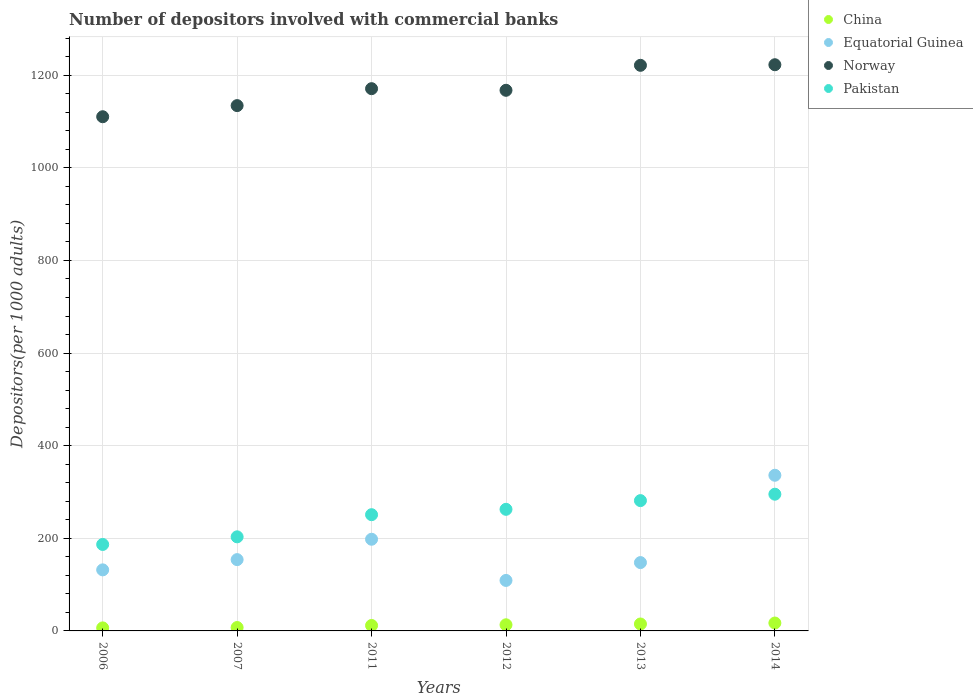How many different coloured dotlines are there?
Give a very brief answer. 4. Is the number of dotlines equal to the number of legend labels?
Ensure brevity in your answer.  Yes. What is the number of depositors involved with commercial banks in China in 2007?
Your response must be concise. 7.35. Across all years, what is the maximum number of depositors involved with commercial banks in Norway?
Ensure brevity in your answer.  1222.66. Across all years, what is the minimum number of depositors involved with commercial banks in Pakistan?
Make the answer very short. 186.7. In which year was the number of depositors involved with commercial banks in China maximum?
Keep it short and to the point. 2014. What is the total number of depositors involved with commercial banks in Pakistan in the graph?
Offer a terse response. 1480.08. What is the difference between the number of depositors involved with commercial banks in Pakistan in 2006 and that in 2013?
Give a very brief answer. -94.68. What is the difference between the number of depositors involved with commercial banks in Pakistan in 2011 and the number of depositors involved with commercial banks in Norway in 2007?
Provide a short and direct response. -883.4. What is the average number of depositors involved with commercial banks in China per year?
Your answer should be compact. 11.81. In the year 2013, what is the difference between the number of depositors involved with commercial banks in China and number of depositors involved with commercial banks in Pakistan?
Keep it short and to the point. -266.42. In how many years, is the number of depositors involved with commercial banks in Pakistan greater than 240?
Provide a succinct answer. 4. What is the ratio of the number of depositors involved with commercial banks in China in 2011 to that in 2013?
Keep it short and to the point. 0.79. Is the difference between the number of depositors involved with commercial banks in China in 2007 and 2012 greater than the difference between the number of depositors involved with commercial banks in Pakistan in 2007 and 2012?
Make the answer very short. Yes. What is the difference between the highest and the second highest number of depositors involved with commercial banks in Pakistan?
Ensure brevity in your answer.  13.85. What is the difference between the highest and the lowest number of depositors involved with commercial banks in China?
Provide a succinct answer. 10.52. Is the sum of the number of depositors involved with commercial banks in Equatorial Guinea in 2012 and 2014 greater than the maximum number of depositors involved with commercial banks in China across all years?
Ensure brevity in your answer.  Yes. Is it the case that in every year, the sum of the number of depositors involved with commercial banks in China and number of depositors involved with commercial banks in Pakistan  is greater than the sum of number of depositors involved with commercial banks in Norway and number of depositors involved with commercial banks in Equatorial Guinea?
Offer a terse response. No. Is it the case that in every year, the sum of the number of depositors involved with commercial banks in Pakistan and number of depositors involved with commercial banks in Equatorial Guinea  is greater than the number of depositors involved with commercial banks in China?
Offer a terse response. Yes. Does the number of depositors involved with commercial banks in Norway monotonically increase over the years?
Your answer should be compact. No. Is the number of depositors involved with commercial banks in China strictly greater than the number of depositors involved with commercial banks in Pakistan over the years?
Keep it short and to the point. No. Is the number of depositors involved with commercial banks in Norway strictly less than the number of depositors involved with commercial banks in China over the years?
Your answer should be very brief. No. How many dotlines are there?
Provide a succinct answer. 4. How many years are there in the graph?
Your answer should be very brief. 6. Where does the legend appear in the graph?
Offer a terse response. Top right. What is the title of the graph?
Your response must be concise. Number of depositors involved with commercial banks. What is the label or title of the Y-axis?
Provide a short and direct response. Depositors(per 1000 adults). What is the Depositors(per 1000 adults) in China in 2006?
Keep it short and to the point. 6.52. What is the Depositors(per 1000 adults) of Equatorial Guinea in 2006?
Provide a short and direct response. 131.85. What is the Depositors(per 1000 adults) in Norway in 2006?
Make the answer very short. 1110.37. What is the Depositors(per 1000 adults) in Pakistan in 2006?
Your answer should be compact. 186.7. What is the Depositors(per 1000 adults) of China in 2007?
Ensure brevity in your answer.  7.35. What is the Depositors(per 1000 adults) in Equatorial Guinea in 2007?
Your response must be concise. 153.97. What is the Depositors(per 1000 adults) of Norway in 2007?
Your response must be concise. 1134.4. What is the Depositors(per 1000 adults) of Pakistan in 2007?
Your answer should be very brief. 203.17. What is the Depositors(per 1000 adults) in China in 2011?
Make the answer very short. 11.75. What is the Depositors(per 1000 adults) of Equatorial Guinea in 2011?
Provide a succinct answer. 197.96. What is the Depositors(per 1000 adults) of Norway in 2011?
Give a very brief answer. 1170.97. What is the Depositors(per 1000 adults) of Pakistan in 2011?
Offer a terse response. 250.99. What is the Depositors(per 1000 adults) in China in 2012?
Give a very brief answer. 13.23. What is the Depositors(per 1000 adults) of Equatorial Guinea in 2012?
Your response must be concise. 109.02. What is the Depositors(per 1000 adults) in Norway in 2012?
Your answer should be very brief. 1167.46. What is the Depositors(per 1000 adults) of Pakistan in 2012?
Ensure brevity in your answer.  262.6. What is the Depositors(per 1000 adults) in China in 2013?
Provide a succinct answer. 14.96. What is the Depositors(per 1000 adults) in Equatorial Guinea in 2013?
Your answer should be very brief. 147.57. What is the Depositors(per 1000 adults) in Norway in 2013?
Ensure brevity in your answer.  1221.4. What is the Depositors(per 1000 adults) of Pakistan in 2013?
Offer a very short reply. 281.38. What is the Depositors(per 1000 adults) in China in 2014?
Offer a terse response. 17.04. What is the Depositors(per 1000 adults) in Equatorial Guinea in 2014?
Provide a succinct answer. 336.14. What is the Depositors(per 1000 adults) in Norway in 2014?
Give a very brief answer. 1222.66. What is the Depositors(per 1000 adults) of Pakistan in 2014?
Keep it short and to the point. 295.23. Across all years, what is the maximum Depositors(per 1000 adults) in China?
Offer a very short reply. 17.04. Across all years, what is the maximum Depositors(per 1000 adults) of Equatorial Guinea?
Keep it short and to the point. 336.14. Across all years, what is the maximum Depositors(per 1000 adults) of Norway?
Your answer should be very brief. 1222.66. Across all years, what is the maximum Depositors(per 1000 adults) in Pakistan?
Provide a short and direct response. 295.23. Across all years, what is the minimum Depositors(per 1000 adults) of China?
Offer a very short reply. 6.52. Across all years, what is the minimum Depositors(per 1000 adults) in Equatorial Guinea?
Your answer should be very brief. 109.02. Across all years, what is the minimum Depositors(per 1000 adults) of Norway?
Provide a succinct answer. 1110.37. Across all years, what is the minimum Depositors(per 1000 adults) of Pakistan?
Your response must be concise. 186.7. What is the total Depositors(per 1000 adults) in China in the graph?
Your response must be concise. 70.86. What is the total Depositors(per 1000 adults) in Equatorial Guinea in the graph?
Ensure brevity in your answer.  1076.51. What is the total Depositors(per 1000 adults) of Norway in the graph?
Keep it short and to the point. 7027.26. What is the total Depositors(per 1000 adults) of Pakistan in the graph?
Your answer should be very brief. 1480.08. What is the difference between the Depositors(per 1000 adults) of China in 2006 and that in 2007?
Your response must be concise. -0.83. What is the difference between the Depositors(per 1000 adults) in Equatorial Guinea in 2006 and that in 2007?
Give a very brief answer. -22.13. What is the difference between the Depositors(per 1000 adults) of Norway in 2006 and that in 2007?
Your answer should be very brief. -24.03. What is the difference between the Depositors(per 1000 adults) of Pakistan in 2006 and that in 2007?
Offer a terse response. -16.47. What is the difference between the Depositors(per 1000 adults) in China in 2006 and that in 2011?
Your answer should be compact. -5.23. What is the difference between the Depositors(per 1000 adults) in Equatorial Guinea in 2006 and that in 2011?
Provide a succinct answer. -66.12. What is the difference between the Depositors(per 1000 adults) of Norway in 2006 and that in 2011?
Your response must be concise. -60.6. What is the difference between the Depositors(per 1000 adults) of Pakistan in 2006 and that in 2011?
Offer a terse response. -64.29. What is the difference between the Depositors(per 1000 adults) in China in 2006 and that in 2012?
Make the answer very short. -6.71. What is the difference between the Depositors(per 1000 adults) of Equatorial Guinea in 2006 and that in 2012?
Your answer should be compact. 22.83. What is the difference between the Depositors(per 1000 adults) of Norway in 2006 and that in 2012?
Provide a succinct answer. -57.1. What is the difference between the Depositors(per 1000 adults) in Pakistan in 2006 and that in 2012?
Ensure brevity in your answer.  -75.9. What is the difference between the Depositors(per 1000 adults) of China in 2006 and that in 2013?
Your response must be concise. -8.44. What is the difference between the Depositors(per 1000 adults) in Equatorial Guinea in 2006 and that in 2013?
Make the answer very short. -15.72. What is the difference between the Depositors(per 1000 adults) in Norway in 2006 and that in 2013?
Make the answer very short. -111.03. What is the difference between the Depositors(per 1000 adults) in Pakistan in 2006 and that in 2013?
Make the answer very short. -94.68. What is the difference between the Depositors(per 1000 adults) in China in 2006 and that in 2014?
Provide a short and direct response. -10.52. What is the difference between the Depositors(per 1000 adults) in Equatorial Guinea in 2006 and that in 2014?
Your answer should be compact. -204.3. What is the difference between the Depositors(per 1000 adults) of Norway in 2006 and that in 2014?
Provide a succinct answer. -112.29. What is the difference between the Depositors(per 1000 adults) in Pakistan in 2006 and that in 2014?
Give a very brief answer. -108.53. What is the difference between the Depositors(per 1000 adults) in China in 2007 and that in 2011?
Your answer should be compact. -4.4. What is the difference between the Depositors(per 1000 adults) of Equatorial Guinea in 2007 and that in 2011?
Offer a terse response. -43.99. What is the difference between the Depositors(per 1000 adults) of Norway in 2007 and that in 2011?
Provide a short and direct response. -36.57. What is the difference between the Depositors(per 1000 adults) of Pakistan in 2007 and that in 2011?
Provide a short and direct response. -47.82. What is the difference between the Depositors(per 1000 adults) in China in 2007 and that in 2012?
Keep it short and to the point. -5.88. What is the difference between the Depositors(per 1000 adults) in Equatorial Guinea in 2007 and that in 2012?
Ensure brevity in your answer.  44.95. What is the difference between the Depositors(per 1000 adults) in Norway in 2007 and that in 2012?
Your answer should be compact. -33.07. What is the difference between the Depositors(per 1000 adults) of Pakistan in 2007 and that in 2012?
Offer a terse response. -59.43. What is the difference between the Depositors(per 1000 adults) in China in 2007 and that in 2013?
Ensure brevity in your answer.  -7.61. What is the difference between the Depositors(per 1000 adults) in Equatorial Guinea in 2007 and that in 2013?
Offer a very short reply. 6.4. What is the difference between the Depositors(per 1000 adults) of Norway in 2007 and that in 2013?
Your answer should be very brief. -87.01. What is the difference between the Depositors(per 1000 adults) in Pakistan in 2007 and that in 2013?
Your answer should be very brief. -78.21. What is the difference between the Depositors(per 1000 adults) in China in 2007 and that in 2014?
Offer a very short reply. -9.69. What is the difference between the Depositors(per 1000 adults) in Equatorial Guinea in 2007 and that in 2014?
Give a very brief answer. -182.17. What is the difference between the Depositors(per 1000 adults) of Norway in 2007 and that in 2014?
Your answer should be compact. -88.26. What is the difference between the Depositors(per 1000 adults) in Pakistan in 2007 and that in 2014?
Offer a terse response. -92.06. What is the difference between the Depositors(per 1000 adults) of China in 2011 and that in 2012?
Keep it short and to the point. -1.48. What is the difference between the Depositors(per 1000 adults) in Equatorial Guinea in 2011 and that in 2012?
Make the answer very short. 88.94. What is the difference between the Depositors(per 1000 adults) in Norway in 2011 and that in 2012?
Your answer should be compact. 3.5. What is the difference between the Depositors(per 1000 adults) in Pakistan in 2011 and that in 2012?
Offer a terse response. -11.61. What is the difference between the Depositors(per 1000 adults) of China in 2011 and that in 2013?
Give a very brief answer. -3.21. What is the difference between the Depositors(per 1000 adults) of Equatorial Guinea in 2011 and that in 2013?
Your answer should be very brief. 50.39. What is the difference between the Depositors(per 1000 adults) of Norway in 2011 and that in 2013?
Give a very brief answer. -50.44. What is the difference between the Depositors(per 1000 adults) in Pakistan in 2011 and that in 2013?
Your response must be concise. -30.39. What is the difference between the Depositors(per 1000 adults) in China in 2011 and that in 2014?
Offer a very short reply. -5.29. What is the difference between the Depositors(per 1000 adults) in Equatorial Guinea in 2011 and that in 2014?
Give a very brief answer. -138.18. What is the difference between the Depositors(per 1000 adults) of Norway in 2011 and that in 2014?
Keep it short and to the point. -51.69. What is the difference between the Depositors(per 1000 adults) in Pakistan in 2011 and that in 2014?
Provide a succinct answer. -44.24. What is the difference between the Depositors(per 1000 adults) in China in 2012 and that in 2013?
Give a very brief answer. -1.73. What is the difference between the Depositors(per 1000 adults) of Equatorial Guinea in 2012 and that in 2013?
Your answer should be very brief. -38.55. What is the difference between the Depositors(per 1000 adults) in Norway in 2012 and that in 2013?
Offer a terse response. -53.94. What is the difference between the Depositors(per 1000 adults) in Pakistan in 2012 and that in 2013?
Your response must be concise. -18.78. What is the difference between the Depositors(per 1000 adults) in China in 2012 and that in 2014?
Your answer should be compact. -3.81. What is the difference between the Depositors(per 1000 adults) in Equatorial Guinea in 2012 and that in 2014?
Give a very brief answer. -227.12. What is the difference between the Depositors(per 1000 adults) of Norway in 2012 and that in 2014?
Keep it short and to the point. -55.2. What is the difference between the Depositors(per 1000 adults) in Pakistan in 2012 and that in 2014?
Offer a very short reply. -32.63. What is the difference between the Depositors(per 1000 adults) in China in 2013 and that in 2014?
Your response must be concise. -2.08. What is the difference between the Depositors(per 1000 adults) in Equatorial Guinea in 2013 and that in 2014?
Offer a very short reply. -188.57. What is the difference between the Depositors(per 1000 adults) in Norway in 2013 and that in 2014?
Keep it short and to the point. -1.26. What is the difference between the Depositors(per 1000 adults) of Pakistan in 2013 and that in 2014?
Ensure brevity in your answer.  -13.85. What is the difference between the Depositors(per 1000 adults) in China in 2006 and the Depositors(per 1000 adults) in Equatorial Guinea in 2007?
Offer a terse response. -147.45. What is the difference between the Depositors(per 1000 adults) in China in 2006 and the Depositors(per 1000 adults) in Norway in 2007?
Offer a terse response. -1127.88. What is the difference between the Depositors(per 1000 adults) of China in 2006 and the Depositors(per 1000 adults) of Pakistan in 2007?
Offer a very short reply. -196.65. What is the difference between the Depositors(per 1000 adults) of Equatorial Guinea in 2006 and the Depositors(per 1000 adults) of Norway in 2007?
Your answer should be very brief. -1002.55. What is the difference between the Depositors(per 1000 adults) of Equatorial Guinea in 2006 and the Depositors(per 1000 adults) of Pakistan in 2007?
Provide a succinct answer. -71.32. What is the difference between the Depositors(per 1000 adults) of Norway in 2006 and the Depositors(per 1000 adults) of Pakistan in 2007?
Make the answer very short. 907.2. What is the difference between the Depositors(per 1000 adults) of China in 2006 and the Depositors(per 1000 adults) of Equatorial Guinea in 2011?
Your response must be concise. -191.44. What is the difference between the Depositors(per 1000 adults) in China in 2006 and the Depositors(per 1000 adults) in Norway in 2011?
Ensure brevity in your answer.  -1164.45. What is the difference between the Depositors(per 1000 adults) of China in 2006 and the Depositors(per 1000 adults) of Pakistan in 2011?
Keep it short and to the point. -244.47. What is the difference between the Depositors(per 1000 adults) of Equatorial Guinea in 2006 and the Depositors(per 1000 adults) of Norway in 2011?
Your answer should be very brief. -1039.12. What is the difference between the Depositors(per 1000 adults) of Equatorial Guinea in 2006 and the Depositors(per 1000 adults) of Pakistan in 2011?
Provide a short and direct response. -119.15. What is the difference between the Depositors(per 1000 adults) in Norway in 2006 and the Depositors(per 1000 adults) in Pakistan in 2011?
Provide a short and direct response. 859.38. What is the difference between the Depositors(per 1000 adults) of China in 2006 and the Depositors(per 1000 adults) of Equatorial Guinea in 2012?
Offer a terse response. -102.5. What is the difference between the Depositors(per 1000 adults) of China in 2006 and the Depositors(per 1000 adults) of Norway in 2012?
Ensure brevity in your answer.  -1160.95. What is the difference between the Depositors(per 1000 adults) in China in 2006 and the Depositors(per 1000 adults) in Pakistan in 2012?
Your answer should be compact. -256.08. What is the difference between the Depositors(per 1000 adults) of Equatorial Guinea in 2006 and the Depositors(per 1000 adults) of Norway in 2012?
Offer a terse response. -1035.62. What is the difference between the Depositors(per 1000 adults) in Equatorial Guinea in 2006 and the Depositors(per 1000 adults) in Pakistan in 2012?
Ensure brevity in your answer.  -130.75. What is the difference between the Depositors(per 1000 adults) in Norway in 2006 and the Depositors(per 1000 adults) in Pakistan in 2012?
Offer a terse response. 847.77. What is the difference between the Depositors(per 1000 adults) in China in 2006 and the Depositors(per 1000 adults) in Equatorial Guinea in 2013?
Offer a terse response. -141.05. What is the difference between the Depositors(per 1000 adults) of China in 2006 and the Depositors(per 1000 adults) of Norway in 2013?
Your answer should be very brief. -1214.88. What is the difference between the Depositors(per 1000 adults) in China in 2006 and the Depositors(per 1000 adults) in Pakistan in 2013?
Give a very brief answer. -274.86. What is the difference between the Depositors(per 1000 adults) of Equatorial Guinea in 2006 and the Depositors(per 1000 adults) of Norway in 2013?
Ensure brevity in your answer.  -1089.56. What is the difference between the Depositors(per 1000 adults) in Equatorial Guinea in 2006 and the Depositors(per 1000 adults) in Pakistan in 2013?
Your response must be concise. -149.53. What is the difference between the Depositors(per 1000 adults) in Norway in 2006 and the Depositors(per 1000 adults) in Pakistan in 2013?
Your answer should be compact. 828.99. What is the difference between the Depositors(per 1000 adults) of China in 2006 and the Depositors(per 1000 adults) of Equatorial Guinea in 2014?
Make the answer very short. -329.62. What is the difference between the Depositors(per 1000 adults) of China in 2006 and the Depositors(per 1000 adults) of Norway in 2014?
Offer a very short reply. -1216.14. What is the difference between the Depositors(per 1000 adults) of China in 2006 and the Depositors(per 1000 adults) of Pakistan in 2014?
Make the answer very short. -288.71. What is the difference between the Depositors(per 1000 adults) in Equatorial Guinea in 2006 and the Depositors(per 1000 adults) in Norway in 2014?
Your answer should be very brief. -1090.82. What is the difference between the Depositors(per 1000 adults) in Equatorial Guinea in 2006 and the Depositors(per 1000 adults) in Pakistan in 2014?
Your response must be concise. -163.39. What is the difference between the Depositors(per 1000 adults) of Norway in 2006 and the Depositors(per 1000 adults) of Pakistan in 2014?
Provide a succinct answer. 815.14. What is the difference between the Depositors(per 1000 adults) of China in 2007 and the Depositors(per 1000 adults) of Equatorial Guinea in 2011?
Your response must be concise. -190.61. What is the difference between the Depositors(per 1000 adults) in China in 2007 and the Depositors(per 1000 adults) in Norway in 2011?
Your answer should be compact. -1163.62. What is the difference between the Depositors(per 1000 adults) of China in 2007 and the Depositors(per 1000 adults) of Pakistan in 2011?
Offer a terse response. -243.64. What is the difference between the Depositors(per 1000 adults) of Equatorial Guinea in 2007 and the Depositors(per 1000 adults) of Norway in 2011?
Give a very brief answer. -1016.99. What is the difference between the Depositors(per 1000 adults) of Equatorial Guinea in 2007 and the Depositors(per 1000 adults) of Pakistan in 2011?
Provide a short and direct response. -97.02. What is the difference between the Depositors(per 1000 adults) of Norway in 2007 and the Depositors(per 1000 adults) of Pakistan in 2011?
Ensure brevity in your answer.  883.4. What is the difference between the Depositors(per 1000 adults) of China in 2007 and the Depositors(per 1000 adults) of Equatorial Guinea in 2012?
Give a very brief answer. -101.67. What is the difference between the Depositors(per 1000 adults) of China in 2007 and the Depositors(per 1000 adults) of Norway in 2012?
Provide a short and direct response. -1160.11. What is the difference between the Depositors(per 1000 adults) in China in 2007 and the Depositors(per 1000 adults) in Pakistan in 2012?
Your answer should be very brief. -255.25. What is the difference between the Depositors(per 1000 adults) in Equatorial Guinea in 2007 and the Depositors(per 1000 adults) in Norway in 2012?
Make the answer very short. -1013.49. What is the difference between the Depositors(per 1000 adults) in Equatorial Guinea in 2007 and the Depositors(per 1000 adults) in Pakistan in 2012?
Give a very brief answer. -108.63. What is the difference between the Depositors(per 1000 adults) of Norway in 2007 and the Depositors(per 1000 adults) of Pakistan in 2012?
Make the answer very short. 871.8. What is the difference between the Depositors(per 1000 adults) of China in 2007 and the Depositors(per 1000 adults) of Equatorial Guinea in 2013?
Ensure brevity in your answer.  -140.22. What is the difference between the Depositors(per 1000 adults) in China in 2007 and the Depositors(per 1000 adults) in Norway in 2013?
Your response must be concise. -1214.05. What is the difference between the Depositors(per 1000 adults) of China in 2007 and the Depositors(per 1000 adults) of Pakistan in 2013?
Offer a very short reply. -274.03. What is the difference between the Depositors(per 1000 adults) in Equatorial Guinea in 2007 and the Depositors(per 1000 adults) in Norway in 2013?
Provide a short and direct response. -1067.43. What is the difference between the Depositors(per 1000 adults) of Equatorial Guinea in 2007 and the Depositors(per 1000 adults) of Pakistan in 2013?
Your response must be concise. -127.41. What is the difference between the Depositors(per 1000 adults) in Norway in 2007 and the Depositors(per 1000 adults) in Pakistan in 2013?
Your answer should be very brief. 853.02. What is the difference between the Depositors(per 1000 adults) of China in 2007 and the Depositors(per 1000 adults) of Equatorial Guinea in 2014?
Make the answer very short. -328.79. What is the difference between the Depositors(per 1000 adults) of China in 2007 and the Depositors(per 1000 adults) of Norway in 2014?
Give a very brief answer. -1215.31. What is the difference between the Depositors(per 1000 adults) in China in 2007 and the Depositors(per 1000 adults) in Pakistan in 2014?
Offer a terse response. -287.88. What is the difference between the Depositors(per 1000 adults) of Equatorial Guinea in 2007 and the Depositors(per 1000 adults) of Norway in 2014?
Your answer should be very brief. -1068.69. What is the difference between the Depositors(per 1000 adults) of Equatorial Guinea in 2007 and the Depositors(per 1000 adults) of Pakistan in 2014?
Your answer should be very brief. -141.26. What is the difference between the Depositors(per 1000 adults) of Norway in 2007 and the Depositors(per 1000 adults) of Pakistan in 2014?
Offer a very short reply. 839.16. What is the difference between the Depositors(per 1000 adults) of China in 2011 and the Depositors(per 1000 adults) of Equatorial Guinea in 2012?
Offer a very short reply. -97.27. What is the difference between the Depositors(per 1000 adults) of China in 2011 and the Depositors(per 1000 adults) of Norway in 2012?
Offer a very short reply. -1155.71. What is the difference between the Depositors(per 1000 adults) of China in 2011 and the Depositors(per 1000 adults) of Pakistan in 2012?
Keep it short and to the point. -250.85. What is the difference between the Depositors(per 1000 adults) of Equatorial Guinea in 2011 and the Depositors(per 1000 adults) of Norway in 2012?
Your answer should be very brief. -969.5. What is the difference between the Depositors(per 1000 adults) of Equatorial Guinea in 2011 and the Depositors(per 1000 adults) of Pakistan in 2012?
Ensure brevity in your answer.  -64.64. What is the difference between the Depositors(per 1000 adults) in Norway in 2011 and the Depositors(per 1000 adults) in Pakistan in 2012?
Provide a short and direct response. 908.37. What is the difference between the Depositors(per 1000 adults) in China in 2011 and the Depositors(per 1000 adults) in Equatorial Guinea in 2013?
Offer a very short reply. -135.82. What is the difference between the Depositors(per 1000 adults) in China in 2011 and the Depositors(per 1000 adults) in Norway in 2013?
Make the answer very short. -1209.65. What is the difference between the Depositors(per 1000 adults) of China in 2011 and the Depositors(per 1000 adults) of Pakistan in 2013?
Offer a terse response. -269.63. What is the difference between the Depositors(per 1000 adults) in Equatorial Guinea in 2011 and the Depositors(per 1000 adults) in Norway in 2013?
Provide a short and direct response. -1023.44. What is the difference between the Depositors(per 1000 adults) in Equatorial Guinea in 2011 and the Depositors(per 1000 adults) in Pakistan in 2013?
Make the answer very short. -83.42. What is the difference between the Depositors(per 1000 adults) of Norway in 2011 and the Depositors(per 1000 adults) of Pakistan in 2013?
Offer a terse response. 889.59. What is the difference between the Depositors(per 1000 adults) in China in 2011 and the Depositors(per 1000 adults) in Equatorial Guinea in 2014?
Your answer should be very brief. -324.39. What is the difference between the Depositors(per 1000 adults) in China in 2011 and the Depositors(per 1000 adults) in Norway in 2014?
Offer a terse response. -1210.91. What is the difference between the Depositors(per 1000 adults) of China in 2011 and the Depositors(per 1000 adults) of Pakistan in 2014?
Ensure brevity in your answer.  -283.48. What is the difference between the Depositors(per 1000 adults) of Equatorial Guinea in 2011 and the Depositors(per 1000 adults) of Norway in 2014?
Your answer should be compact. -1024.7. What is the difference between the Depositors(per 1000 adults) of Equatorial Guinea in 2011 and the Depositors(per 1000 adults) of Pakistan in 2014?
Give a very brief answer. -97.27. What is the difference between the Depositors(per 1000 adults) in Norway in 2011 and the Depositors(per 1000 adults) in Pakistan in 2014?
Make the answer very short. 875.73. What is the difference between the Depositors(per 1000 adults) in China in 2012 and the Depositors(per 1000 adults) in Equatorial Guinea in 2013?
Make the answer very short. -134.34. What is the difference between the Depositors(per 1000 adults) of China in 2012 and the Depositors(per 1000 adults) of Norway in 2013?
Your answer should be very brief. -1208.17. What is the difference between the Depositors(per 1000 adults) in China in 2012 and the Depositors(per 1000 adults) in Pakistan in 2013?
Provide a succinct answer. -268.15. What is the difference between the Depositors(per 1000 adults) in Equatorial Guinea in 2012 and the Depositors(per 1000 adults) in Norway in 2013?
Ensure brevity in your answer.  -1112.38. What is the difference between the Depositors(per 1000 adults) in Equatorial Guinea in 2012 and the Depositors(per 1000 adults) in Pakistan in 2013?
Your answer should be compact. -172.36. What is the difference between the Depositors(per 1000 adults) of Norway in 2012 and the Depositors(per 1000 adults) of Pakistan in 2013?
Offer a terse response. 886.08. What is the difference between the Depositors(per 1000 adults) of China in 2012 and the Depositors(per 1000 adults) of Equatorial Guinea in 2014?
Ensure brevity in your answer.  -322.91. What is the difference between the Depositors(per 1000 adults) of China in 2012 and the Depositors(per 1000 adults) of Norway in 2014?
Ensure brevity in your answer.  -1209.43. What is the difference between the Depositors(per 1000 adults) in China in 2012 and the Depositors(per 1000 adults) in Pakistan in 2014?
Your answer should be compact. -282. What is the difference between the Depositors(per 1000 adults) in Equatorial Guinea in 2012 and the Depositors(per 1000 adults) in Norway in 2014?
Ensure brevity in your answer.  -1113.64. What is the difference between the Depositors(per 1000 adults) of Equatorial Guinea in 2012 and the Depositors(per 1000 adults) of Pakistan in 2014?
Keep it short and to the point. -186.21. What is the difference between the Depositors(per 1000 adults) in Norway in 2012 and the Depositors(per 1000 adults) in Pakistan in 2014?
Keep it short and to the point. 872.23. What is the difference between the Depositors(per 1000 adults) in China in 2013 and the Depositors(per 1000 adults) in Equatorial Guinea in 2014?
Provide a short and direct response. -321.18. What is the difference between the Depositors(per 1000 adults) in China in 2013 and the Depositors(per 1000 adults) in Norway in 2014?
Ensure brevity in your answer.  -1207.7. What is the difference between the Depositors(per 1000 adults) of China in 2013 and the Depositors(per 1000 adults) of Pakistan in 2014?
Give a very brief answer. -280.27. What is the difference between the Depositors(per 1000 adults) in Equatorial Guinea in 2013 and the Depositors(per 1000 adults) in Norway in 2014?
Provide a short and direct response. -1075.09. What is the difference between the Depositors(per 1000 adults) of Equatorial Guinea in 2013 and the Depositors(per 1000 adults) of Pakistan in 2014?
Give a very brief answer. -147.66. What is the difference between the Depositors(per 1000 adults) of Norway in 2013 and the Depositors(per 1000 adults) of Pakistan in 2014?
Give a very brief answer. 926.17. What is the average Depositors(per 1000 adults) of China per year?
Offer a very short reply. 11.81. What is the average Depositors(per 1000 adults) of Equatorial Guinea per year?
Ensure brevity in your answer.  179.42. What is the average Depositors(per 1000 adults) of Norway per year?
Your answer should be compact. 1171.21. What is the average Depositors(per 1000 adults) in Pakistan per year?
Give a very brief answer. 246.68. In the year 2006, what is the difference between the Depositors(per 1000 adults) in China and Depositors(per 1000 adults) in Equatorial Guinea?
Keep it short and to the point. -125.33. In the year 2006, what is the difference between the Depositors(per 1000 adults) of China and Depositors(per 1000 adults) of Norway?
Ensure brevity in your answer.  -1103.85. In the year 2006, what is the difference between the Depositors(per 1000 adults) of China and Depositors(per 1000 adults) of Pakistan?
Provide a succinct answer. -180.18. In the year 2006, what is the difference between the Depositors(per 1000 adults) of Equatorial Guinea and Depositors(per 1000 adults) of Norway?
Make the answer very short. -978.52. In the year 2006, what is the difference between the Depositors(per 1000 adults) in Equatorial Guinea and Depositors(per 1000 adults) in Pakistan?
Provide a short and direct response. -54.86. In the year 2006, what is the difference between the Depositors(per 1000 adults) of Norway and Depositors(per 1000 adults) of Pakistan?
Ensure brevity in your answer.  923.67. In the year 2007, what is the difference between the Depositors(per 1000 adults) in China and Depositors(per 1000 adults) in Equatorial Guinea?
Ensure brevity in your answer.  -146.62. In the year 2007, what is the difference between the Depositors(per 1000 adults) of China and Depositors(per 1000 adults) of Norway?
Your answer should be very brief. -1127.05. In the year 2007, what is the difference between the Depositors(per 1000 adults) in China and Depositors(per 1000 adults) in Pakistan?
Ensure brevity in your answer.  -195.82. In the year 2007, what is the difference between the Depositors(per 1000 adults) of Equatorial Guinea and Depositors(per 1000 adults) of Norway?
Provide a succinct answer. -980.42. In the year 2007, what is the difference between the Depositors(per 1000 adults) in Equatorial Guinea and Depositors(per 1000 adults) in Pakistan?
Give a very brief answer. -49.2. In the year 2007, what is the difference between the Depositors(per 1000 adults) in Norway and Depositors(per 1000 adults) in Pakistan?
Ensure brevity in your answer.  931.23. In the year 2011, what is the difference between the Depositors(per 1000 adults) in China and Depositors(per 1000 adults) in Equatorial Guinea?
Your answer should be compact. -186.21. In the year 2011, what is the difference between the Depositors(per 1000 adults) in China and Depositors(per 1000 adults) in Norway?
Ensure brevity in your answer.  -1159.22. In the year 2011, what is the difference between the Depositors(per 1000 adults) in China and Depositors(per 1000 adults) in Pakistan?
Provide a succinct answer. -239.24. In the year 2011, what is the difference between the Depositors(per 1000 adults) of Equatorial Guinea and Depositors(per 1000 adults) of Norway?
Make the answer very short. -973. In the year 2011, what is the difference between the Depositors(per 1000 adults) of Equatorial Guinea and Depositors(per 1000 adults) of Pakistan?
Your answer should be compact. -53.03. In the year 2011, what is the difference between the Depositors(per 1000 adults) of Norway and Depositors(per 1000 adults) of Pakistan?
Provide a short and direct response. 919.97. In the year 2012, what is the difference between the Depositors(per 1000 adults) of China and Depositors(per 1000 adults) of Equatorial Guinea?
Keep it short and to the point. -95.79. In the year 2012, what is the difference between the Depositors(per 1000 adults) of China and Depositors(per 1000 adults) of Norway?
Your answer should be very brief. -1154.23. In the year 2012, what is the difference between the Depositors(per 1000 adults) in China and Depositors(per 1000 adults) in Pakistan?
Offer a very short reply. -249.37. In the year 2012, what is the difference between the Depositors(per 1000 adults) in Equatorial Guinea and Depositors(per 1000 adults) in Norway?
Your response must be concise. -1058.45. In the year 2012, what is the difference between the Depositors(per 1000 adults) in Equatorial Guinea and Depositors(per 1000 adults) in Pakistan?
Provide a succinct answer. -153.58. In the year 2012, what is the difference between the Depositors(per 1000 adults) in Norway and Depositors(per 1000 adults) in Pakistan?
Keep it short and to the point. 904.87. In the year 2013, what is the difference between the Depositors(per 1000 adults) of China and Depositors(per 1000 adults) of Equatorial Guinea?
Offer a very short reply. -132.61. In the year 2013, what is the difference between the Depositors(per 1000 adults) in China and Depositors(per 1000 adults) in Norway?
Give a very brief answer. -1206.44. In the year 2013, what is the difference between the Depositors(per 1000 adults) in China and Depositors(per 1000 adults) in Pakistan?
Offer a very short reply. -266.42. In the year 2013, what is the difference between the Depositors(per 1000 adults) in Equatorial Guinea and Depositors(per 1000 adults) in Norway?
Give a very brief answer. -1073.83. In the year 2013, what is the difference between the Depositors(per 1000 adults) of Equatorial Guinea and Depositors(per 1000 adults) of Pakistan?
Ensure brevity in your answer.  -133.81. In the year 2013, what is the difference between the Depositors(per 1000 adults) of Norway and Depositors(per 1000 adults) of Pakistan?
Give a very brief answer. 940.02. In the year 2014, what is the difference between the Depositors(per 1000 adults) of China and Depositors(per 1000 adults) of Equatorial Guinea?
Offer a terse response. -319.1. In the year 2014, what is the difference between the Depositors(per 1000 adults) in China and Depositors(per 1000 adults) in Norway?
Provide a succinct answer. -1205.62. In the year 2014, what is the difference between the Depositors(per 1000 adults) in China and Depositors(per 1000 adults) in Pakistan?
Provide a short and direct response. -278.19. In the year 2014, what is the difference between the Depositors(per 1000 adults) of Equatorial Guinea and Depositors(per 1000 adults) of Norway?
Give a very brief answer. -886.52. In the year 2014, what is the difference between the Depositors(per 1000 adults) in Equatorial Guinea and Depositors(per 1000 adults) in Pakistan?
Provide a short and direct response. 40.91. In the year 2014, what is the difference between the Depositors(per 1000 adults) of Norway and Depositors(per 1000 adults) of Pakistan?
Ensure brevity in your answer.  927.43. What is the ratio of the Depositors(per 1000 adults) of China in 2006 to that in 2007?
Your answer should be very brief. 0.89. What is the ratio of the Depositors(per 1000 adults) in Equatorial Guinea in 2006 to that in 2007?
Provide a succinct answer. 0.86. What is the ratio of the Depositors(per 1000 adults) in Norway in 2006 to that in 2007?
Ensure brevity in your answer.  0.98. What is the ratio of the Depositors(per 1000 adults) in Pakistan in 2006 to that in 2007?
Your answer should be compact. 0.92. What is the ratio of the Depositors(per 1000 adults) of China in 2006 to that in 2011?
Make the answer very short. 0.55. What is the ratio of the Depositors(per 1000 adults) in Equatorial Guinea in 2006 to that in 2011?
Keep it short and to the point. 0.67. What is the ratio of the Depositors(per 1000 adults) in Norway in 2006 to that in 2011?
Your response must be concise. 0.95. What is the ratio of the Depositors(per 1000 adults) of Pakistan in 2006 to that in 2011?
Offer a very short reply. 0.74. What is the ratio of the Depositors(per 1000 adults) in China in 2006 to that in 2012?
Give a very brief answer. 0.49. What is the ratio of the Depositors(per 1000 adults) of Equatorial Guinea in 2006 to that in 2012?
Offer a terse response. 1.21. What is the ratio of the Depositors(per 1000 adults) in Norway in 2006 to that in 2012?
Give a very brief answer. 0.95. What is the ratio of the Depositors(per 1000 adults) of Pakistan in 2006 to that in 2012?
Provide a short and direct response. 0.71. What is the ratio of the Depositors(per 1000 adults) in China in 2006 to that in 2013?
Provide a short and direct response. 0.44. What is the ratio of the Depositors(per 1000 adults) in Equatorial Guinea in 2006 to that in 2013?
Offer a terse response. 0.89. What is the ratio of the Depositors(per 1000 adults) in Pakistan in 2006 to that in 2013?
Keep it short and to the point. 0.66. What is the ratio of the Depositors(per 1000 adults) in China in 2006 to that in 2014?
Offer a terse response. 0.38. What is the ratio of the Depositors(per 1000 adults) in Equatorial Guinea in 2006 to that in 2014?
Your answer should be compact. 0.39. What is the ratio of the Depositors(per 1000 adults) in Norway in 2006 to that in 2014?
Keep it short and to the point. 0.91. What is the ratio of the Depositors(per 1000 adults) in Pakistan in 2006 to that in 2014?
Keep it short and to the point. 0.63. What is the ratio of the Depositors(per 1000 adults) in China in 2007 to that in 2011?
Your response must be concise. 0.63. What is the ratio of the Depositors(per 1000 adults) in Norway in 2007 to that in 2011?
Offer a very short reply. 0.97. What is the ratio of the Depositors(per 1000 adults) of Pakistan in 2007 to that in 2011?
Your answer should be very brief. 0.81. What is the ratio of the Depositors(per 1000 adults) in China in 2007 to that in 2012?
Make the answer very short. 0.56. What is the ratio of the Depositors(per 1000 adults) of Equatorial Guinea in 2007 to that in 2012?
Provide a short and direct response. 1.41. What is the ratio of the Depositors(per 1000 adults) in Norway in 2007 to that in 2012?
Ensure brevity in your answer.  0.97. What is the ratio of the Depositors(per 1000 adults) of Pakistan in 2007 to that in 2012?
Make the answer very short. 0.77. What is the ratio of the Depositors(per 1000 adults) of China in 2007 to that in 2013?
Make the answer very short. 0.49. What is the ratio of the Depositors(per 1000 adults) of Equatorial Guinea in 2007 to that in 2013?
Provide a succinct answer. 1.04. What is the ratio of the Depositors(per 1000 adults) of Norway in 2007 to that in 2013?
Your answer should be very brief. 0.93. What is the ratio of the Depositors(per 1000 adults) of Pakistan in 2007 to that in 2013?
Provide a succinct answer. 0.72. What is the ratio of the Depositors(per 1000 adults) of China in 2007 to that in 2014?
Provide a short and direct response. 0.43. What is the ratio of the Depositors(per 1000 adults) in Equatorial Guinea in 2007 to that in 2014?
Your answer should be compact. 0.46. What is the ratio of the Depositors(per 1000 adults) of Norway in 2007 to that in 2014?
Your response must be concise. 0.93. What is the ratio of the Depositors(per 1000 adults) in Pakistan in 2007 to that in 2014?
Ensure brevity in your answer.  0.69. What is the ratio of the Depositors(per 1000 adults) of China in 2011 to that in 2012?
Provide a short and direct response. 0.89. What is the ratio of the Depositors(per 1000 adults) in Equatorial Guinea in 2011 to that in 2012?
Provide a short and direct response. 1.82. What is the ratio of the Depositors(per 1000 adults) of Norway in 2011 to that in 2012?
Provide a succinct answer. 1. What is the ratio of the Depositors(per 1000 adults) of Pakistan in 2011 to that in 2012?
Your response must be concise. 0.96. What is the ratio of the Depositors(per 1000 adults) of China in 2011 to that in 2013?
Your response must be concise. 0.79. What is the ratio of the Depositors(per 1000 adults) of Equatorial Guinea in 2011 to that in 2013?
Ensure brevity in your answer.  1.34. What is the ratio of the Depositors(per 1000 adults) of Norway in 2011 to that in 2013?
Your answer should be very brief. 0.96. What is the ratio of the Depositors(per 1000 adults) of Pakistan in 2011 to that in 2013?
Your answer should be very brief. 0.89. What is the ratio of the Depositors(per 1000 adults) in China in 2011 to that in 2014?
Make the answer very short. 0.69. What is the ratio of the Depositors(per 1000 adults) in Equatorial Guinea in 2011 to that in 2014?
Your answer should be very brief. 0.59. What is the ratio of the Depositors(per 1000 adults) in Norway in 2011 to that in 2014?
Give a very brief answer. 0.96. What is the ratio of the Depositors(per 1000 adults) in Pakistan in 2011 to that in 2014?
Provide a short and direct response. 0.85. What is the ratio of the Depositors(per 1000 adults) in China in 2012 to that in 2013?
Your answer should be very brief. 0.88. What is the ratio of the Depositors(per 1000 adults) of Equatorial Guinea in 2012 to that in 2013?
Your response must be concise. 0.74. What is the ratio of the Depositors(per 1000 adults) of Norway in 2012 to that in 2013?
Provide a succinct answer. 0.96. What is the ratio of the Depositors(per 1000 adults) of China in 2012 to that in 2014?
Ensure brevity in your answer.  0.78. What is the ratio of the Depositors(per 1000 adults) of Equatorial Guinea in 2012 to that in 2014?
Ensure brevity in your answer.  0.32. What is the ratio of the Depositors(per 1000 adults) of Norway in 2012 to that in 2014?
Offer a very short reply. 0.95. What is the ratio of the Depositors(per 1000 adults) in Pakistan in 2012 to that in 2014?
Provide a short and direct response. 0.89. What is the ratio of the Depositors(per 1000 adults) of China in 2013 to that in 2014?
Provide a succinct answer. 0.88. What is the ratio of the Depositors(per 1000 adults) of Equatorial Guinea in 2013 to that in 2014?
Your response must be concise. 0.44. What is the ratio of the Depositors(per 1000 adults) in Norway in 2013 to that in 2014?
Offer a terse response. 1. What is the ratio of the Depositors(per 1000 adults) of Pakistan in 2013 to that in 2014?
Offer a terse response. 0.95. What is the difference between the highest and the second highest Depositors(per 1000 adults) of China?
Provide a short and direct response. 2.08. What is the difference between the highest and the second highest Depositors(per 1000 adults) of Equatorial Guinea?
Ensure brevity in your answer.  138.18. What is the difference between the highest and the second highest Depositors(per 1000 adults) in Norway?
Offer a terse response. 1.26. What is the difference between the highest and the second highest Depositors(per 1000 adults) of Pakistan?
Ensure brevity in your answer.  13.85. What is the difference between the highest and the lowest Depositors(per 1000 adults) in China?
Your answer should be compact. 10.52. What is the difference between the highest and the lowest Depositors(per 1000 adults) in Equatorial Guinea?
Offer a very short reply. 227.12. What is the difference between the highest and the lowest Depositors(per 1000 adults) of Norway?
Give a very brief answer. 112.29. What is the difference between the highest and the lowest Depositors(per 1000 adults) of Pakistan?
Offer a terse response. 108.53. 